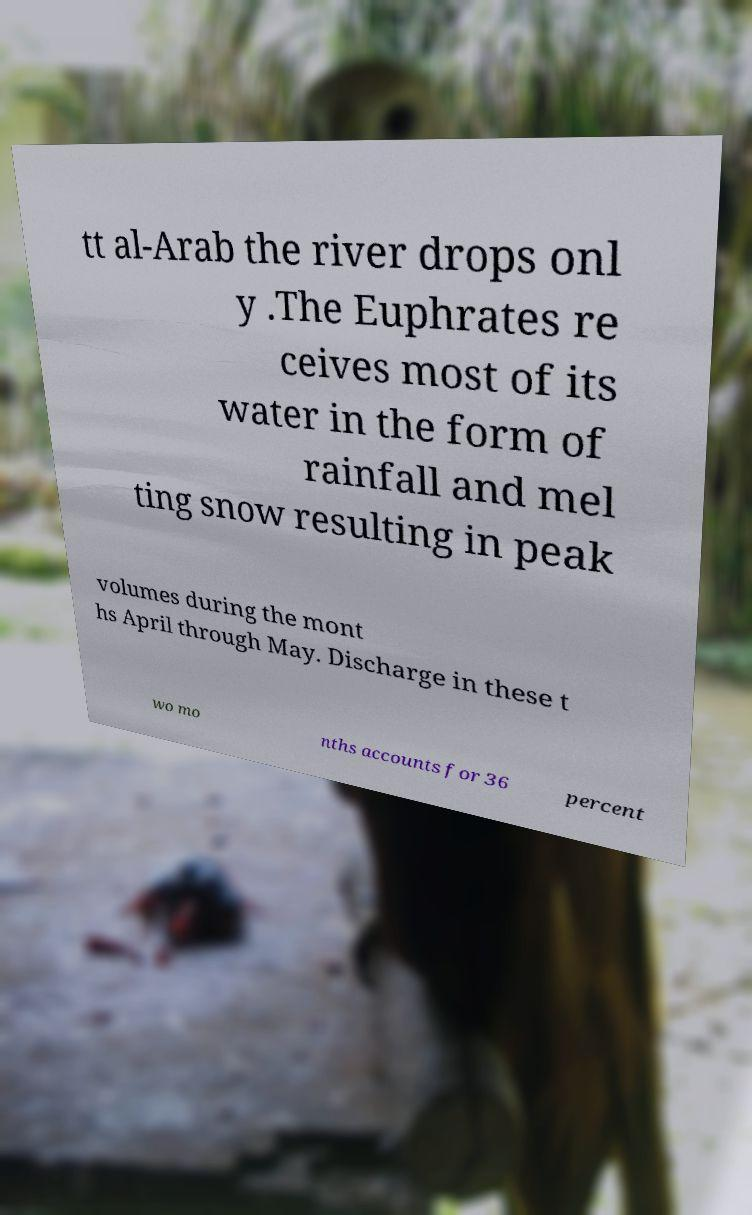Please identify and transcribe the text found in this image. tt al-Arab the river drops onl y .The Euphrates re ceives most of its water in the form of rainfall and mel ting snow resulting in peak volumes during the mont hs April through May. Discharge in these t wo mo nths accounts for 36 percent 